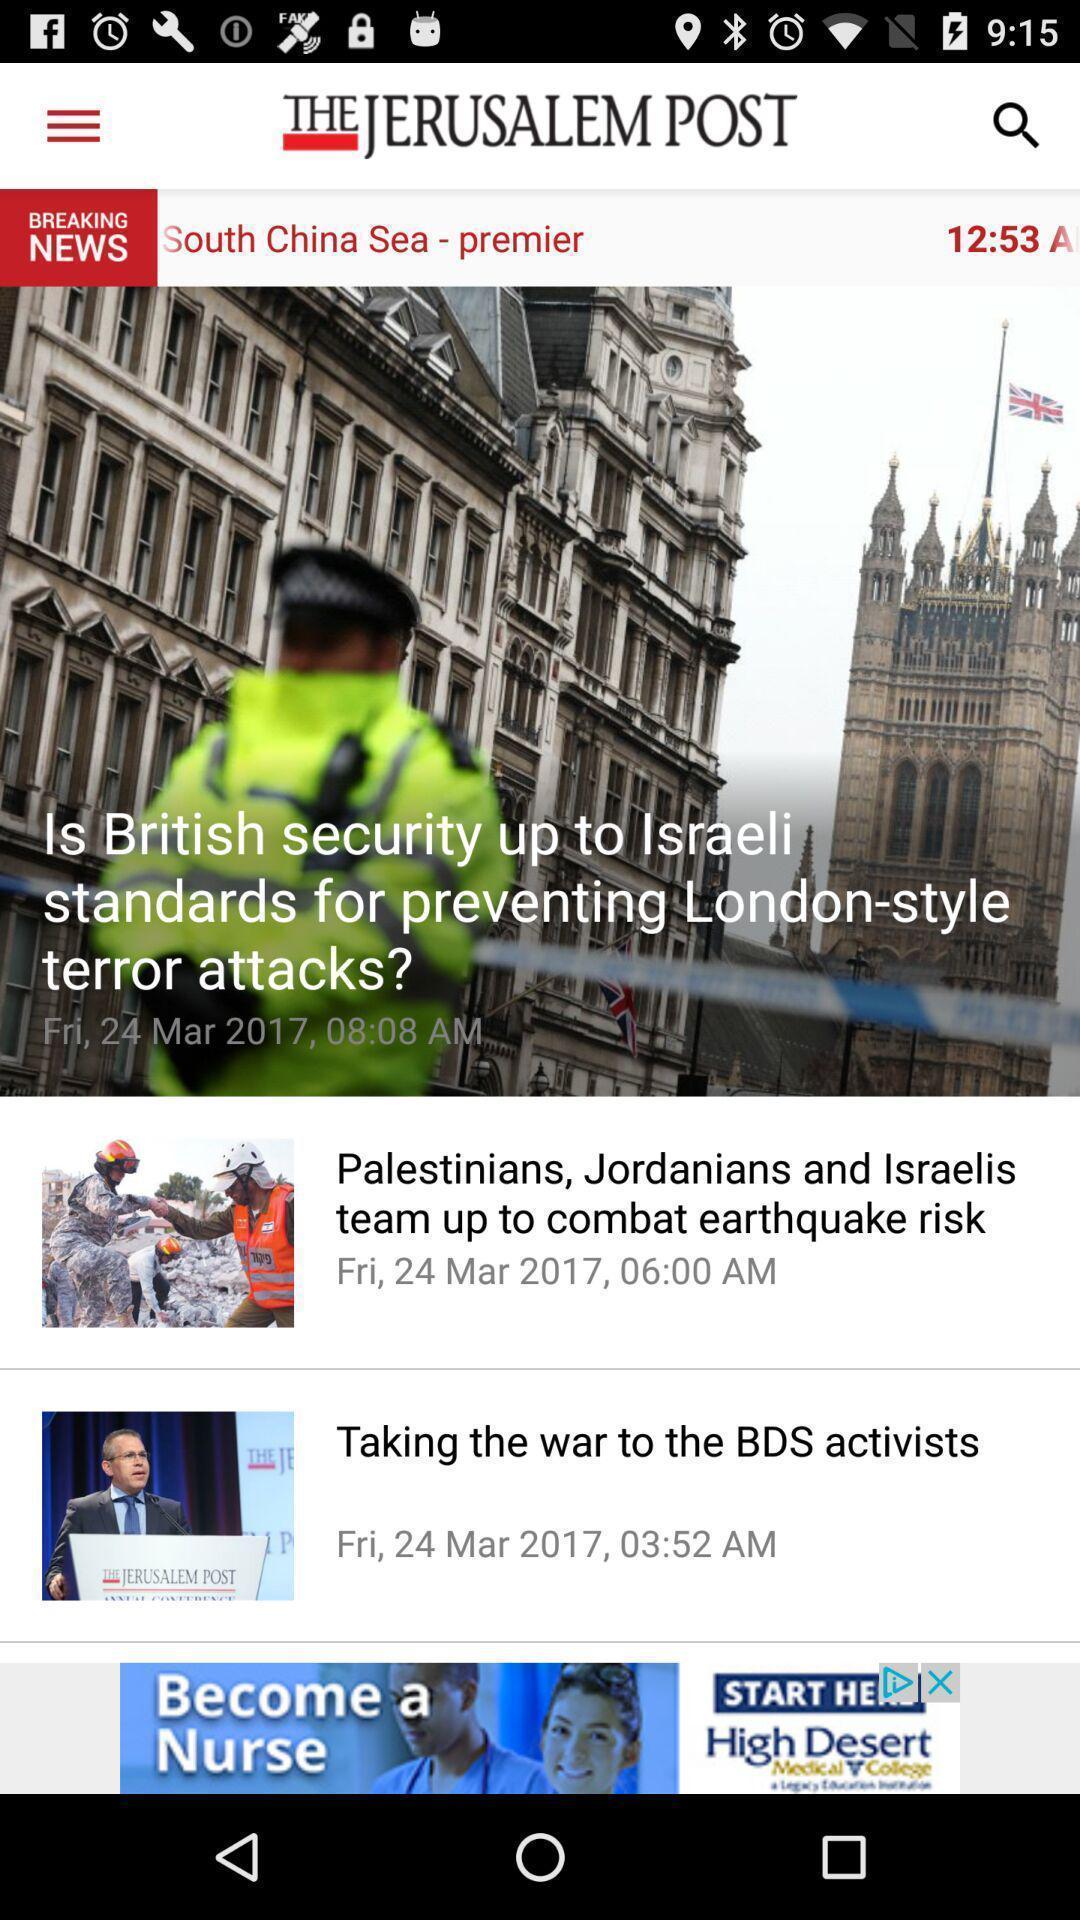Summarize the information in this screenshot. Various articles displayed of a news app. 